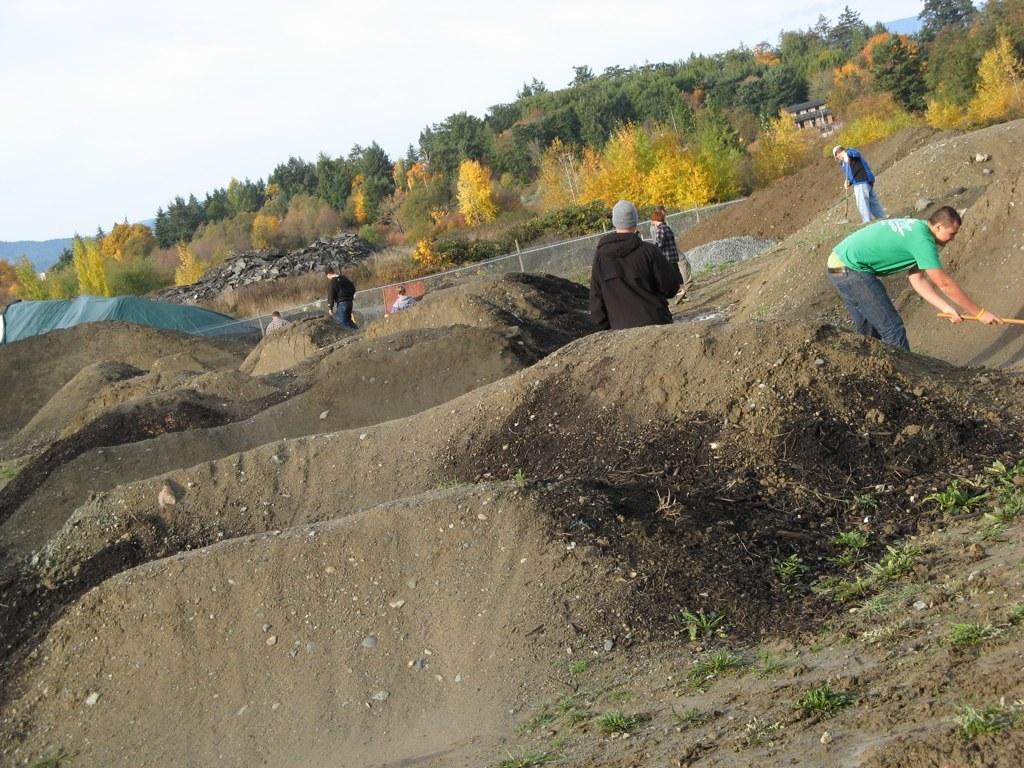Could you give a brief overview of what you see in this image? In this picture we can see a group of people standing, sand, trees, fence, house and in the background we can see sky. 